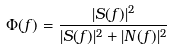Convert formula to latex. <formula><loc_0><loc_0><loc_500><loc_500>\Phi ( f ) = \frac { | S ( f ) | ^ { 2 } } { | S ( f ) | ^ { 2 } + | N ( f ) | ^ { 2 } }</formula> 